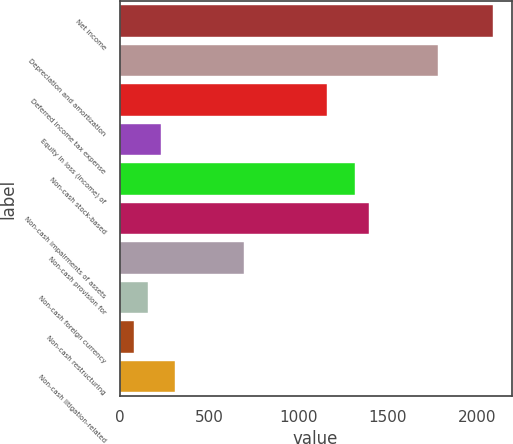<chart> <loc_0><loc_0><loc_500><loc_500><bar_chart><fcel>Net income<fcel>Depreciation and amortization<fcel>Deferred income tax expense<fcel>Equity in loss (income) of<fcel>Non-cash stock-based<fcel>Non-cash impairments of assets<fcel>Non-cash provision for<fcel>Non-cash foreign currency<fcel>Non-cash restructuring<fcel>Non-cash litigation-related<nl><fcel>2088.47<fcel>1779.23<fcel>1160.75<fcel>233.03<fcel>1315.37<fcel>1392.68<fcel>696.89<fcel>155.72<fcel>78.41<fcel>310.34<nl></chart> 